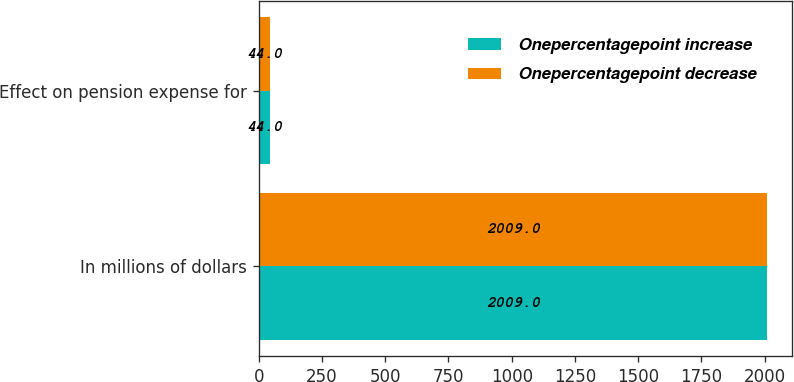Convert chart to OTSL. <chart><loc_0><loc_0><loc_500><loc_500><stacked_bar_chart><ecel><fcel>In millions of dollars<fcel>Effect on pension expense for<nl><fcel>Onepercentagepoint increase<fcel>2009<fcel>44<nl><fcel>Onepercentagepoint decrease<fcel>2009<fcel>44<nl></chart> 